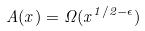Convert formula to latex. <formula><loc_0><loc_0><loc_500><loc_500>A ( x ) = \Omega ( x ^ { 1 / 2 - \epsilon } )</formula> 